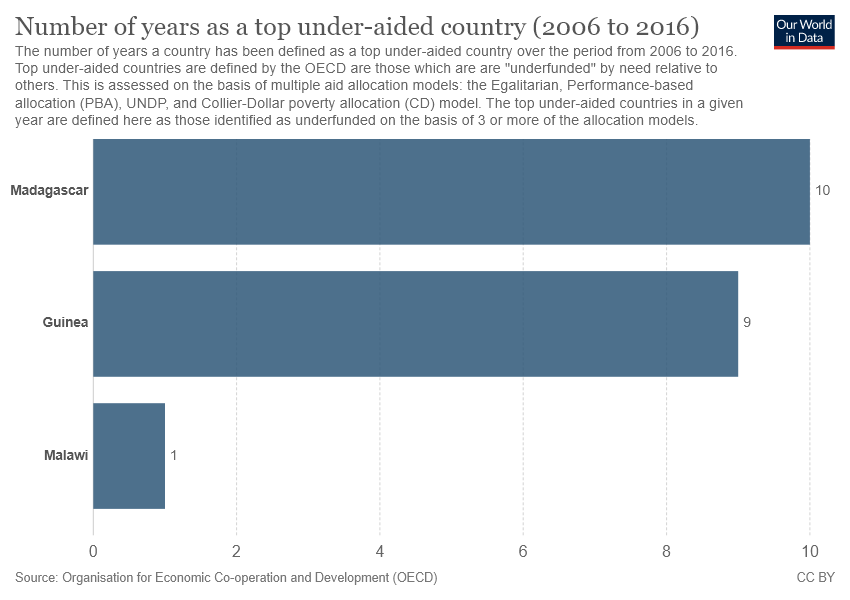Mention a couple of crucial points in this snapshot. There is one color in the graph. The sum of all three bars is 20. 